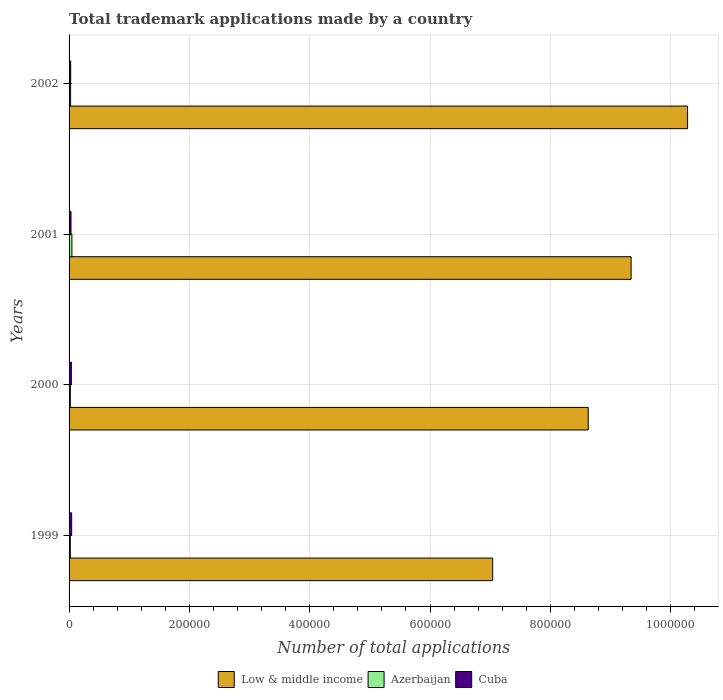How many groups of bars are there?
Give a very brief answer. 4. In how many cases, is the number of bars for a given year not equal to the number of legend labels?
Provide a short and direct response. 0. What is the number of applications made by in Cuba in 2002?
Your answer should be compact. 2665. Across all years, what is the maximum number of applications made by in Azerbaijan?
Ensure brevity in your answer.  4703. Across all years, what is the minimum number of applications made by in Cuba?
Offer a terse response. 2665. In which year was the number of applications made by in Low & middle income minimum?
Offer a terse response. 1999. What is the total number of applications made by in Low & middle income in the graph?
Make the answer very short. 3.53e+06. What is the difference between the number of applications made by in Azerbaijan in 2001 and that in 2002?
Offer a terse response. 2167. What is the difference between the number of applications made by in Low & middle income in 1999 and the number of applications made by in Azerbaijan in 2002?
Your answer should be very brief. 7.02e+05. What is the average number of applications made by in Cuba per year?
Your answer should be compact. 3544.25. In the year 2001, what is the difference between the number of applications made by in Cuba and number of applications made by in Low & middle income?
Your answer should be very brief. -9.31e+05. In how many years, is the number of applications made by in Azerbaijan greater than 40000 ?
Offer a very short reply. 0. What is the ratio of the number of applications made by in Low & middle income in 2001 to that in 2002?
Offer a very short reply. 0.91. Is the number of applications made by in Azerbaijan in 2001 less than that in 2002?
Provide a succinct answer. No. Is the difference between the number of applications made by in Cuba in 1999 and 2001 greater than the difference between the number of applications made by in Low & middle income in 1999 and 2001?
Your response must be concise. Yes. What is the difference between the highest and the second highest number of applications made by in Low & middle income?
Your answer should be compact. 9.38e+04. What is the difference between the highest and the lowest number of applications made by in Low & middle income?
Keep it short and to the point. 3.24e+05. What does the 2nd bar from the top in 2001 represents?
Your answer should be very brief. Azerbaijan. What does the 3rd bar from the bottom in 2000 represents?
Offer a terse response. Cuba. Is it the case that in every year, the sum of the number of applications made by in Azerbaijan and number of applications made by in Low & middle income is greater than the number of applications made by in Cuba?
Provide a succinct answer. Yes. Are all the bars in the graph horizontal?
Provide a short and direct response. Yes. How many years are there in the graph?
Your response must be concise. 4. Does the graph contain any zero values?
Keep it short and to the point. No. Does the graph contain grids?
Your answer should be very brief. Yes. Where does the legend appear in the graph?
Your answer should be compact. Bottom center. How many legend labels are there?
Your answer should be compact. 3. How are the legend labels stacked?
Provide a short and direct response. Horizontal. What is the title of the graph?
Make the answer very short. Total trademark applications made by a country. What is the label or title of the X-axis?
Provide a short and direct response. Number of total applications. What is the label or title of the Y-axis?
Provide a short and direct response. Years. What is the Number of total applications in Low & middle income in 1999?
Offer a terse response. 7.04e+05. What is the Number of total applications of Azerbaijan in 1999?
Make the answer very short. 2094. What is the Number of total applications of Cuba in 1999?
Provide a succinct answer. 4310. What is the Number of total applications of Low & middle income in 2000?
Offer a very short reply. 8.63e+05. What is the Number of total applications in Azerbaijan in 2000?
Your answer should be compact. 2144. What is the Number of total applications in Cuba in 2000?
Give a very brief answer. 4003. What is the Number of total applications in Low & middle income in 2001?
Make the answer very short. 9.34e+05. What is the Number of total applications of Azerbaijan in 2001?
Provide a succinct answer. 4703. What is the Number of total applications of Cuba in 2001?
Provide a short and direct response. 3199. What is the Number of total applications in Low & middle income in 2002?
Give a very brief answer. 1.03e+06. What is the Number of total applications in Azerbaijan in 2002?
Your response must be concise. 2536. What is the Number of total applications of Cuba in 2002?
Ensure brevity in your answer.  2665. Across all years, what is the maximum Number of total applications of Low & middle income?
Give a very brief answer. 1.03e+06. Across all years, what is the maximum Number of total applications in Azerbaijan?
Provide a succinct answer. 4703. Across all years, what is the maximum Number of total applications in Cuba?
Your answer should be compact. 4310. Across all years, what is the minimum Number of total applications in Low & middle income?
Provide a succinct answer. 7.04e+05. Across all years, what is the minimum Number of total applications in Azerbaijan?
Give a very brief answer. 2094. Across all years, what is the minimum Number of total applications in Cuba?
Provide a succinct answer. 2665. What is the total Number of total applications of Low & middle income in the graph?
Offer a terse response. 3.53e+06. What is the total Number of total applications in Azerbaijan in the graph?
Offer a very short reply. 1.15e+04. What is the total Number of total applications in Cuba in the graph?
Your answer should be compact. 1.42e+04. What is the difference between the Number of total applications in Low & middle income in 1999 and that in 2000?
Give a very brief answer. -1.59e+05. What is the difference between the Number of total applications in Azerbaijan in 1999 and that in 2000?
Your response must be concise. -50. What is the difference between the Number of total applications of Cuba in 1999 and that in 2000?
Your answer should be very brief. 307. What is the difference between the Number of total applications of Low & middle income in 1999 and that in 2001?
Ensure brevity in your answer.  -2.30e+05. What is the difference between the Number of total applications in Azerbaijan in 1999 and that in 2001?
Ensure brevity in your answer.  -2609. What is the difference between the Number of total applications in Cuba in 1999 and that in 2001?
Ensure brevity in your answer.  1111. What is the difference between the Number of total applications of Low & middle income in 1999 and that in 2002?
Provide a short and direct response. -3.24e+05. What is the difference between the Number of total applications in Azerbaijan in 1999 and that in 2002?
Ensure brevity in your answer.  -442. What is the difference between the Number of total applications of Cuba in 1999 and that in 2002?
Offer a terse response. 1645. What is the difference between the Number of total applications of Low & middle income in 2000 and that in 2001?
Your answer should be compact. -7.13e+04. What is the difference between the Number of total applications in Azerbaijan in 2000 and that in 2001?
Ensure brevity in your answer.  -2559. What is the difference between the Number of total applications in Cuba in 2000 and that in 2001?
Offer a very short reply. 804. What is the difference between the Number of total applications in Low & middle income in 2000 and that in 2002?
Your answer should be compact. -1.65e+05. What is the difference between the Number of total applications in Azerbaijan in 2000 and that in 2002?
Your answer should be very brief. -392. What is the difference between the Number of total applications in Cuba in 2000 and that in 2002?
Ensure brevity in your answer.  1338. What is the difference between the Number of total applications of Low & middle income in 2001 and that in 2002?
Give a very brief answer. -9.38e+04. What is the difference between the Number of total applications in Azerbaijan in 2001 and that in 2002?
Offer a terse response. 2167. What is the difference between the Number of total applications in Cuba in 2001 and that in 2002?
Provide a succinct answer. 534. What is the difference between the Number of total applications of Low & middle income in 1999 and the Number of total applications of Azerbaijan in 2000?
Your answer should be compact. 7.02e+05. What is the difference between the Number of total applications in Low & middle income in 1999 and the Number of total applications in Cuba in 2000?
Keep it short and to the point. 7.00e+05. What is the difference between the Number of total applications of Azerbaijan in 1999 and the Number of total applications of Cuba in 2000?
Provide a short and direct response. -1909. What is the difference between the Number of total applications of Low & middle income in 1999 and the Number of total applications of Azerbaijan in 2001?
Your answer should be very brief. 6.99e+05. What is the difference between the Number of total applications in Low & middle income in 1999 and the Number of total applications in Cuba in 2001?
Offer a very short reply. 7.01e+05. What is the difference between the Number of total applications of Azerbaijan in 1999 and the Number of total applications of Cuba in 2001?
Provide a short and direct response. -1105. What is the difference between the Number of total applications of Low & middle income in 1999 and the Number of total applications of Azerbaijan in 2002?
Keep it short and to the point. 7.02e+05. What is the difference between the Number of total applications of Low & middle income in 1999 and the Number of total applications of Cuba in 2002?
Your answer should be compact. 7.01e+05. What is the difference between the Number of total applications of Azerbaijan in 1999 and the Number of total applications of Cuba in 2002?
Keep it short and to the point. -571. What is the difference between the Number of total applications in Low & middle income in 2000 and the Number of total applications in Azerbaijan in 2001?
Your answer should be very brief. 8.58e+05. What is the difference between the Number of total applications of Low & middle income in 2000 and the Number of total applications of Cuba in 2001?
Your answer should be very brief. 8.60e+05. What is the difference between the Number of total applications in Azerbaijan in 2000 and the Number of total applications in Cuba in 2001?
Give a very brief answer. -1055. What is the difference between the Number of total applications of Low & middle income in 2000 and the Number of total applications of Azerbaijan in 2002?
Provide a short and direct response. 8.60e+05. What is the difference between the Number of total applications of Low & middle income in 2000 and the Number of total applications of Cuba in 2002?
Provide a short and direct response. 8.60e+05. What is the difference between the Number of total applications in Azerbaijan in 2000 and the Number of total applications in Cuba in 2002?
Provide a short and direct response. -521. What is the difference between the Number of total applications in Low & middle income in 2001 and the Number of total applications in Azerbaijan in 2002?
Offer a very short reply. 9.32e+05. What is the difference between the Number of total applications in Low & middle income in 2001 and the Number of total applications in Cuba in 2002?
Provide a short and direct response. 9.32e+05. What is the difference between the Number of total applications in Azerbaijan in 2001 and the Number of total applications in Cuba in 2002?
Provide a short and direct response. 2038. What is the average Number of total applications of Low & middle income per year?
Offer a terse response. 8.82e+05. What is the average Number of total applications in Azerbaijan per year?
Your answer should be compact. 2869.25. What is the average Number of total applications in Cuba per year?
Your answer should be very brief. 3544.25. In the year 1999, what is the difference between the Number of total applications in Low & middle income and Number of total applications in Azerbaijan?
Your answer should be very brief. 7.02e+05. In the year 1999, what is the difference between the Number of total applications of Low & middle income and Number of total applications of Cuba?
Your response must be concise. 7.00e+05. In the year 1999, what is the difference between the Number of total applications of Azerbaijan and Number of total applications of Cuba?
Provide a short and direct response. -2216. In the year 2000, what is the difference between the Number of total applications of Low & middle income and Number of total applications of Azerbaijan?
Your answer should be compact. 8.61e+05. In the year 2000, what is the difference between the Number of total applications in Low & middle income and Number of total applications in Cuba?
Ensure brevity in your answer.  8.59e+05. In the year 2000, what is the difference between the Number of total applications of Azerbaijan and Number of total applications of Cuba?
Your response must be concise. -1859. In the year 2001, what is the difference between the Number of total applications of Low & middle income and Number of total applications of Azerbaijan?
Offer a terse response. 9.30e+05. In the year 2001, what is the difference between the Number of total applications of Low & middle income and Number of total applications of Cuba?
Keep it short and to the point. 9.31e+05. In the year 2001, what is the difference between the Number of total applications of Azerbaijan and Number of total applications of Cuba?
Provide a succinct answer. 1504. In the year 2002, what is the difference between the Number of total applications in Low & middle income and Number of total applications in Azerbaijan?
Provide a short and direct response. 1.03e+06. In the year 2002, what is the difference between the Number of total applications of Low & middle income and Number of total applications of Cuba?
Offer a very short reply. 1.03e+06. In the year 2002, what is the difference between the Number of total applications in Azerbaijan and Number of total applications in Cuba?
Your answer should be compact. -129. What is the ratio of the Number of total applications in Low & middle income in 1999 to that in 2000?
Offer a terse response. 0.82. What is the ratio of the Number of total applications of Azerbaijan in 1999 to that in 2000?
Make the answer very short. 0.98. What is the ratio of the Number of total applications of Cuba in 1999 to that in 2000?
Ensure brevity in your answer.  1.08. What is the ratio of the Number of total applications of Low & middle income in 1999 to that in 2001?
Your response must be concise. 0.75. What is the ratio of the Number of total applications in Azerbaijan in 1999 to that in 2001?
Provide a succinct answer. 0.45. What is the ratio of the Number of total applications in Cuba in 1999 to that in 2001?
Offer a terse response. 1.35. What is the ratio of the Number of total applications of Low & middle income in 1999 to that in 2002?
Keep it short and to the point. 0.68. What is the ratio of the Number of total applications in Azerbaijan in 1999 to that in 2002?
Your answer should be very brief. 0.83. What is the ratio of the Number of total applications in Cuba in 1999 to that in 2002?
Keep it short and to the point. 1.62. What is the ratio of the Number of total applications in Low & middle income in 2000 to that in 2001?
Make the answer very short. 0.92. What is the ratio of the Number of total applications of Azerbaijan in 2000 to that in 2001?
Keep it short and to the point. 0.46. What is the ratio of the Number of total applications in Cuba in 2000 to that in 2001?
Offer a very short reply. 1.25. What is the ratio of the Number of total applications of Low & middle income in 2000 to that in 2002?
Ensure brevity in your answer.  0.84. What is the ratio of the Number of total applications of Azerbaijan in 2000 to that in 2002?
Keep it short and to the point. 0.85. What is the ratio of the Number of total applications of Cuba in 2000 to that in 2002?
Your answer should be compact. 1.5. What is the ratio of the Number of total applications in Low & middle income in 2001 to that in 2002?
Offer a very short reply. 0.91. What is the ratio of the Number of total applications in Azerbaijan in 2001 to that in 2002?
Your answer should be very brief. 1.85. What is the ratio of the Number of total applications of Cuba in 2001 to that in 2002?
Keep it short and to the point. 1.2. What is the difference between the highest and the second highest Number of total applications in Low & middle income?
Your response must be concise. 9.38e+04. What is the difference between the highest and the second highest Number of total applications in Azerbaijan?
Your answer should be very brief. 2167. What is the difference between the highest and the second highest Number of total applications of Cuba?
Ensure brevity in your answer.  307. What is the difference between the highest and the lowest Number of total applications of Low & middle income?
Offer a terse response. 3.24e+05. What is the difference between the highest and the lowest Number of total applications in Azerbaijan?
Offer a terse response. 2609. What is the difference between the highest and the lowest Number of total applications in Cuba?
Give a very brief answer. 1645. 